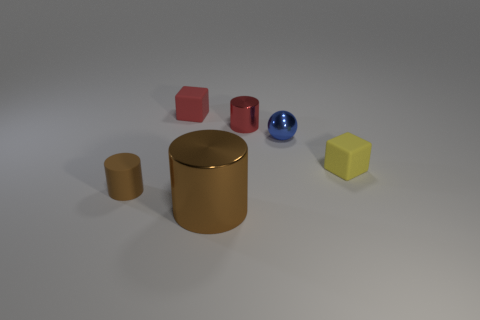Subtract all purple spheres. How many brown cylinders are left? 2 Subtract all large metal cylinders. How many cylinders are left? 2 Subtract 1 cylinders. How many cylinders are left? 2 Add 2 purple objects. How many objects exist? 8 Subtract all blocks. How many objects are left? 4 Subtract all cyan cylinders. Subtract all brown balls. How many cylinders are left? 3 Subtract all large cyan matte things. Subtract all cylinders. How many objects are left? 3 Add 6 red rubber things. How many red rubber things are left? 7 Add 2 brown metal things. How many brown metal things exist? 3 Subtract 0 green balls. How many objects are left? 6 